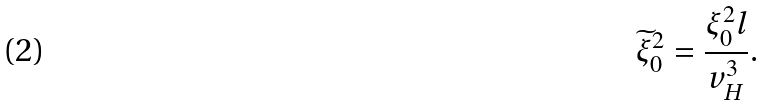<formula> <loc_0><loc_0><loc_500><loc_500>\widetilde { \xi } _ { 0 } ^ { 2 } = \frac { \xi _ { 0 } ^ { 2 } l } { v _ { H } ^ { 3 } } .</formula> 